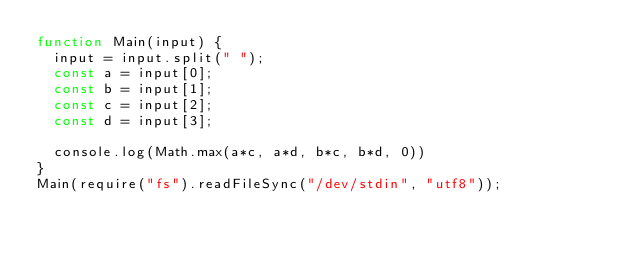<code> <loc_0><loc_0><loc_500><loc_500><_JavaScript_>function Main(input) {
  input = input.split(" ");
  const a = input[0];
  const b = input[1];
  const c = input[2];
  const d = input[3];

  console.log(Math.max(a*c, a*d, b*c, b*d, 0))
}
Main(require("fs").readFileSync("/dev/stdin", "utf8"));</code> 